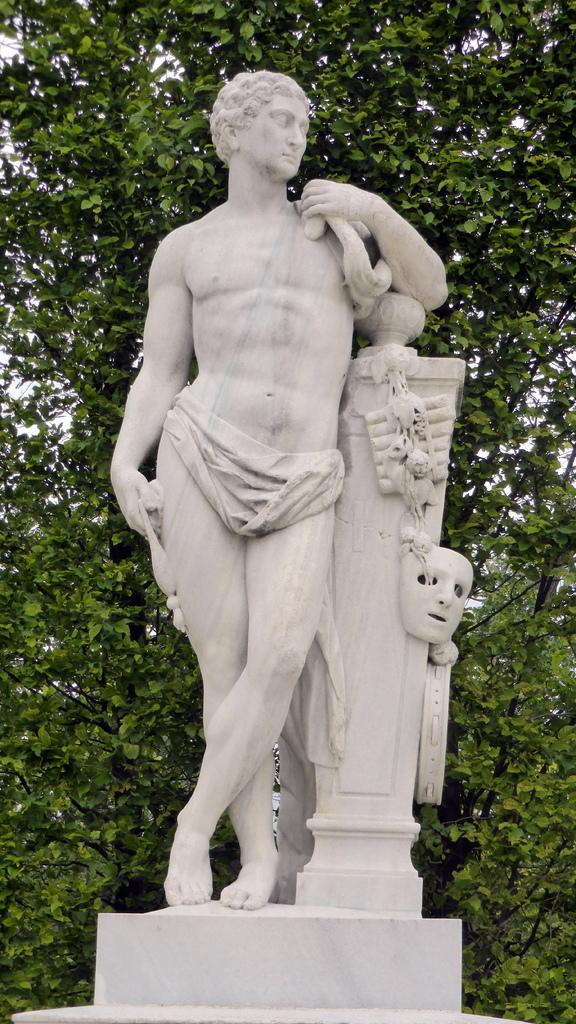Could you give a brief overview of what you see in this image? In the middle of the picture, we see the statue of the man standing. In the background, there are trees. 